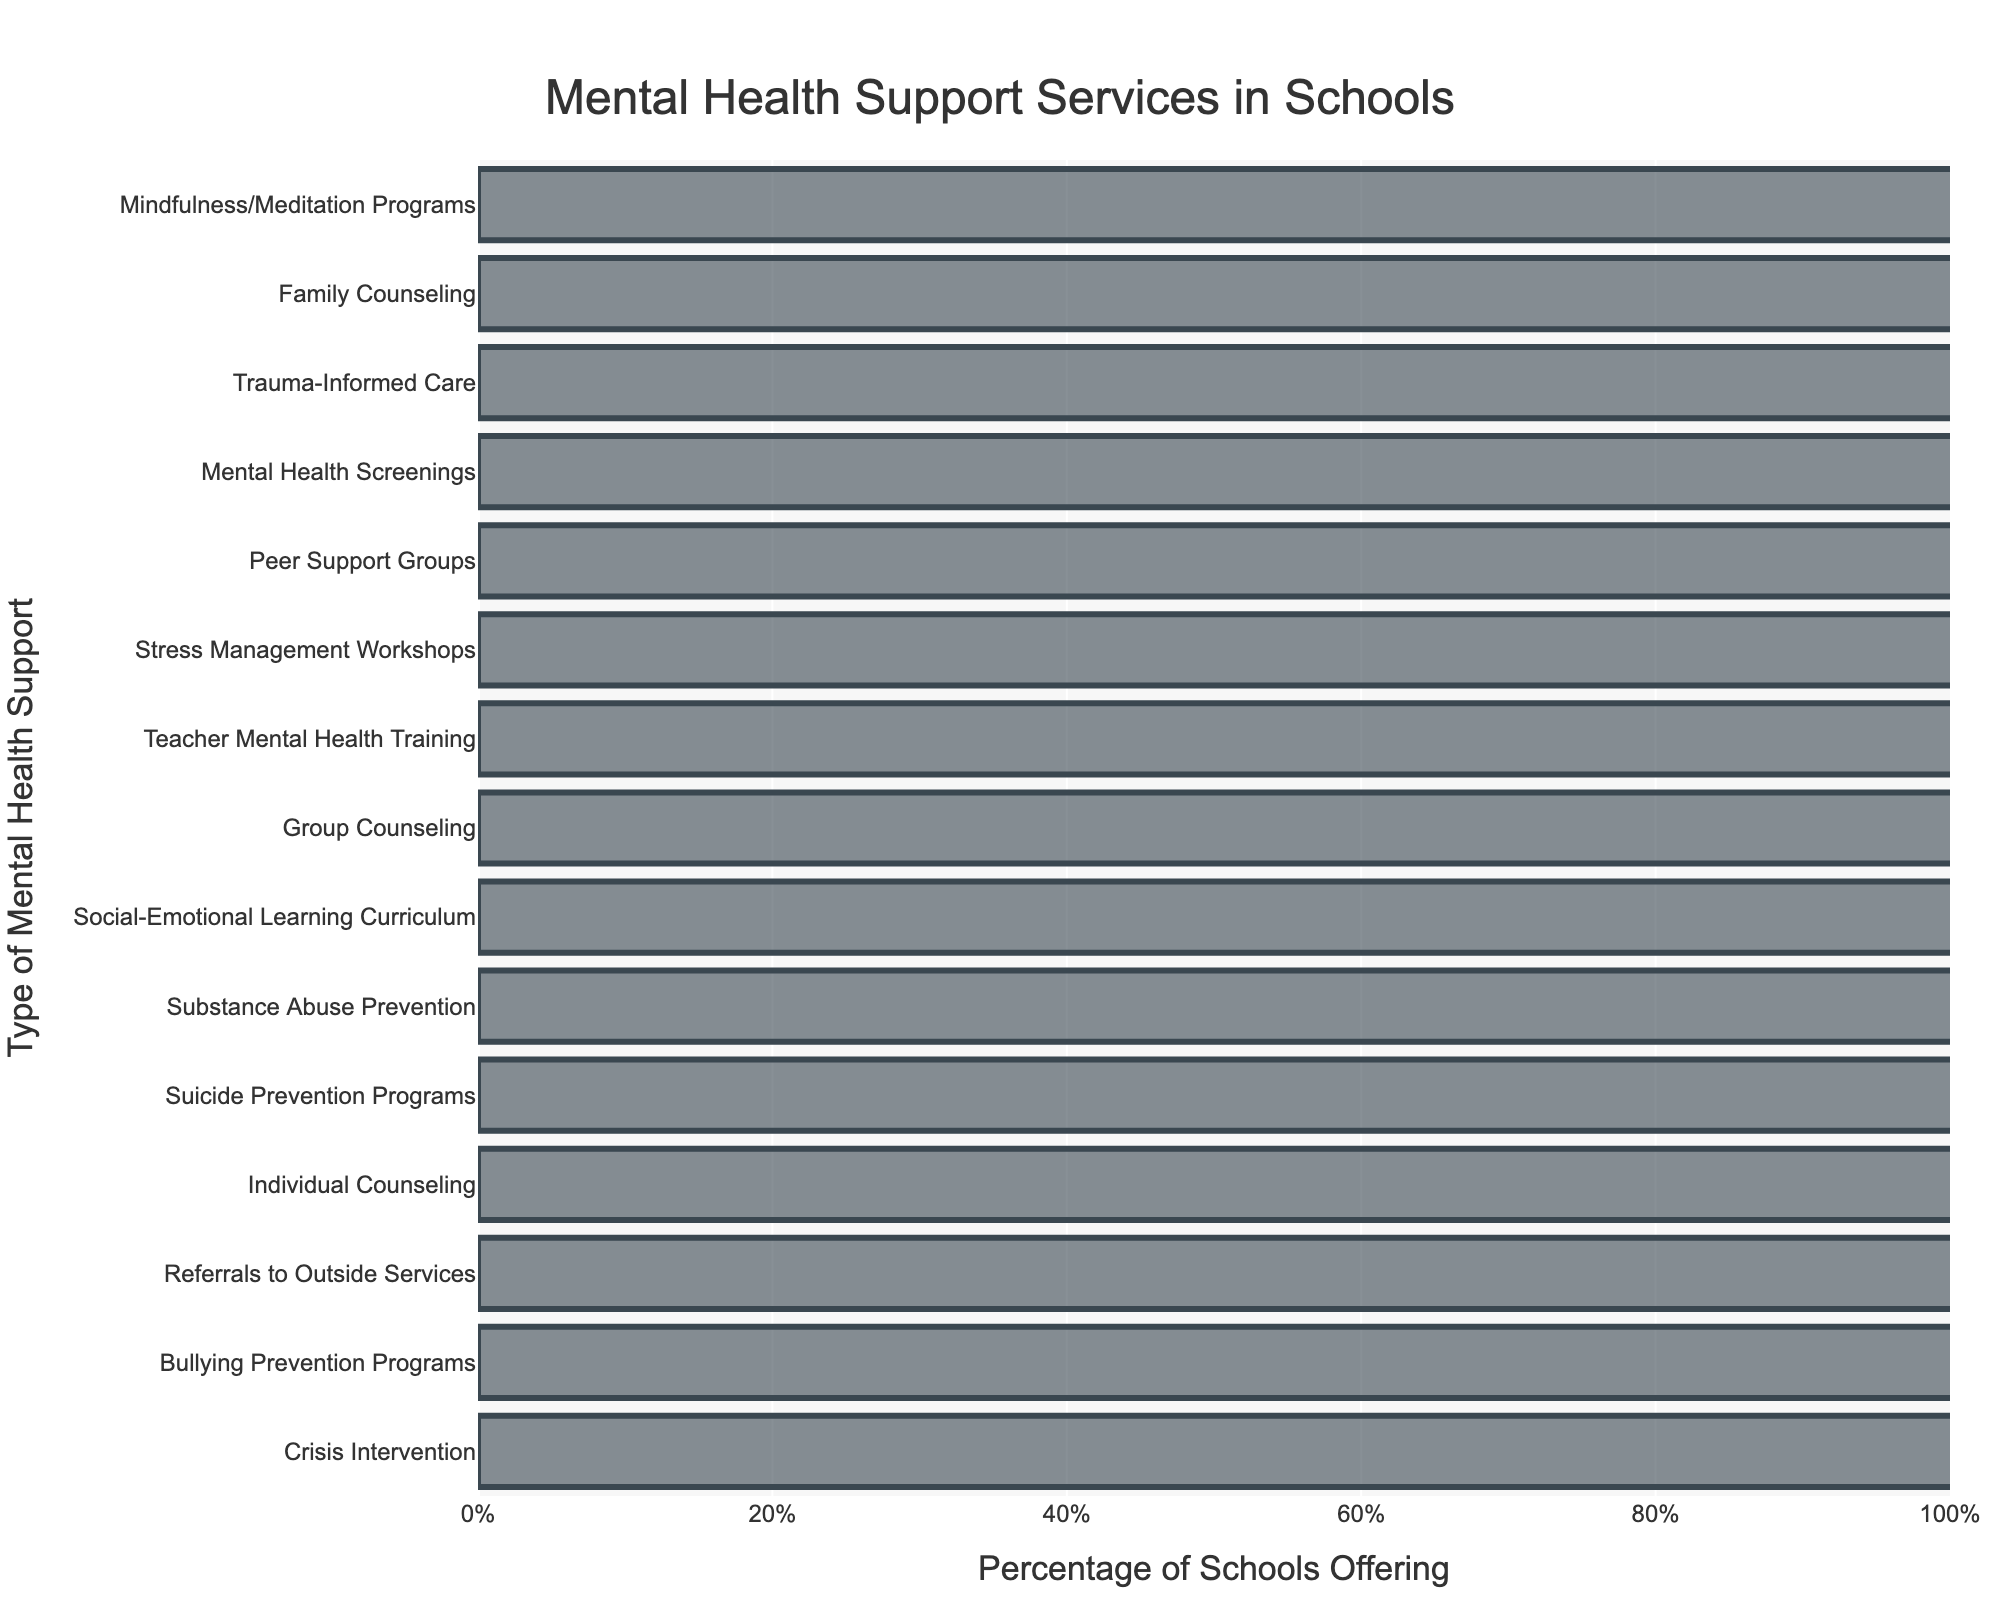What type of mental health support service is offered by the highest percentage of schools? The type of mental health support service offered by the highest percentage of schools is the one with the tallest bar in the chart. Crisis Intervention has the tallest bar.
Answer: Crisis Intervention What is the difference in percentage between schools offering Mindfulness/Meditation Programs and those offering Stress Management Workshops? Locate the percentages for both Mindfulness/Meditation Programs (40%) and Stress Management Workshops (62%), then subtract the smaller percentage from the larger percentage: 62% - 40% = 22%.
Answer: 22% Which three types of mental health support services are offered by less than 50% of schools? Look for the bars that are shorter than the 50% mark on the x-axis. These are Family Counseling (45%), Mindfulness/Meditation Programs (40%), and Trauma-Informed Care (50%).
Answer: Family Counseling, Mindfulness/Meditation Programs, Trauma-Informed Care How many types of mental health support services are offered by more than 75% of schools? Count the bars that extend beyond the 75% mark on the x-axis: Crisis Intervention, Individual Counseling, Referrals to Outside Services, Bullying Prevention Programs, and Suicide Prevention Programs.
Answer: 5 What is the average percentage of schools offering Group Counseling, Peer Support Groups, and Family Counseling? Find the percentages for Group Counseling (70%), Peer Support Groups (58%), and Family Counseling (45%), then compute the average: (70% + 58% + 45%) / 3 ≈ (173%) / 3 = 57.67%.
Answer: 57.67% Which mental health support service is offered by exactly 75% of schools? Identify the bar whose length corresponds exactly to 75%. This service is Substance Abuse Prevention.
Answer: Substance Abuse Prevention Is Teacher Mental Health Training offered by a higher percentage of schools compared to Social-Emotional Learning Curriculum? Compare the bars' lengths: Teacher Mental Health Training (65%) and Social-Emotional Learning Curriculum (72%). The latter is longer.
Answer: No What is the second most commonly offered type of mental health support service? Identify the second tallest bar after Crisis Intervention, which corresponds to Bullying Prevention Programs at 90%.
Answer: Bullying Prevention Programs What percentage of schools offer both Trauma-Informed Care and Mental Health Screenings? Identify the percentages for both Trauma-Informed Care (50%) and Mental Health Screenings (55%), and note that both percentages are below 60%.
Answer: Trauma-Informed Care (50%) and Mental Health Screenings (55%) 